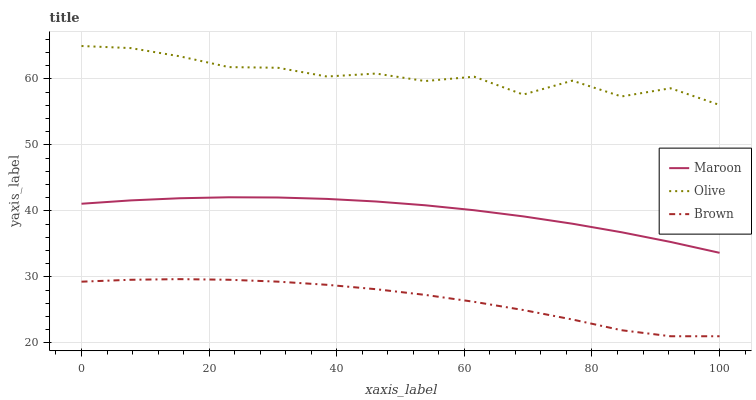Does Brown have the minimum area under the curve?
Answer yes or no. Yes. Does Olive have the maximum area under the curve?
Answer yes or no. Yes. Does Maroon have the minimum area under the curve?
Answer yes or no. No. Does Maroon have the maximum area under the curve?
Answer yes or no. No. Is Maroon the smoothest?
Answer yes or no. Yes. Is Olive the roughest?
Answer yes or no. Yes. Is Brown the smoothest?
Answer yes or no. No. Is Brown the roughest?
Answer yes or no. No. Does Brown have the lowest value?
Answer yes or no. Yes. Does Maroon have the lowest value?
Answer yes or no. No. Does Olive have the highest value?
Answer yes or no. Yes. Does Maroon have the highest value?
Answer yes or no. No. Is Maroon less than Olive?
Answer yes or no. Yes. Is Olive greater than Maroon?
Answer yes or no. Yes. Does Maroon intersect Olive?
Answer yes or no. No. 